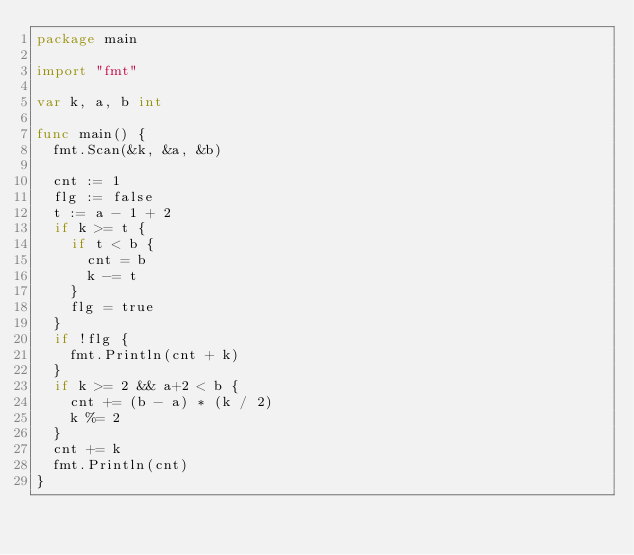<code> <loc_0><loc_0><loc_500><loc_500><_Go_>package main

import "fmt"

var k, a, b int

func main() {
	fmt.Scan(&k, &a, &b)

	cnt := 1
	flg := false
	t := a - 1 + 2
	if k >= t {
		if t < b {
			cnt = b
			k -= t
		}
		flg = true
	}
	if !flg {
		fmt.Println(cnt + k)
	}
	if k >= 2 && a+2 < b {
		cnt += (b - a) * (k / 2)
		k %= 2
	}
	cnt += k
	fmt.Println(cnt)
}
</code> 